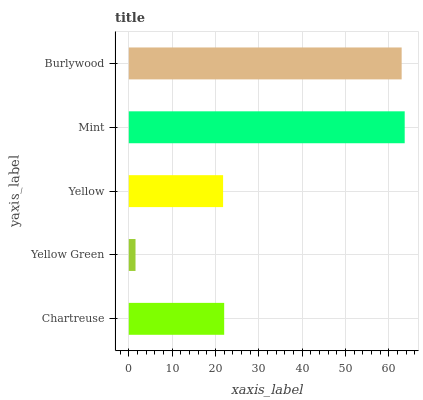Is Yellow Green the minimum?
Answer yes or no. Yes. Is Mint the maximum?
Answer yes or no. Yes. Is Yellow the minimum?
Answer yes or no. No. Is Yellow the maximum?
Answer yes or no. No. Is Yellow greater than Yellow Green?
Answer yes or no. Yes. Is Yellow Green less than Yellow?
Answer yes or no. Yes. Is Yellow Green greater than Yellow?
Answer yes or no. No. Is Yellow less than Yellow Green?
Answer yes or no. No. Is Chartreuse the high median?
Answer yes or no. Yes. Is Chartreuse the low median?
Answer yes or no. Yes. Is Burlywood the high median?
Answer yes or no. No. Is Yellow Green the low median?
Answer yes or no. No. 